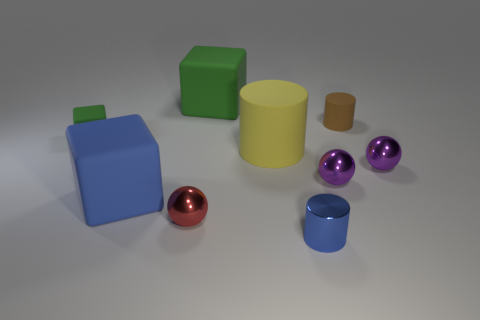Is there any other thing that is made of the same material as the red ball?
Your response must be concise. Yes. There is a small blue thing; is it the same shape as the purple object left of the brown cylinder?
Ensure brevity in your answer.  No. How many other things are the same shape as the yellow thing?
Your response must be concise. 2. There is a object that is both behind the small metal cylinder and in front of the blue cube; what is its color?
Provide a succinct answer. Red. The tiny metallic cylinder is what color?
Make the answer very short. Blue. Are the blue cube and the blue thing that is right of the big cylinder made of the same material?
Offer a very short reply. No. What is the shape of the tiny red thing that is the same material as the small blue cylinder?
Make the answer very short. Sphere. There is a matte cube that is the same size as the blue cylinder; what is its color?
Your response must be concise. Green. Do the shiny object that is to the left of the blue shiny cylinder and the brown rubber cylinder have the same size?
Your response must be concise. Yes. Do the small rubber cylinder and the tiny rubber block have the same color?
Provide a short and direct response. No. 